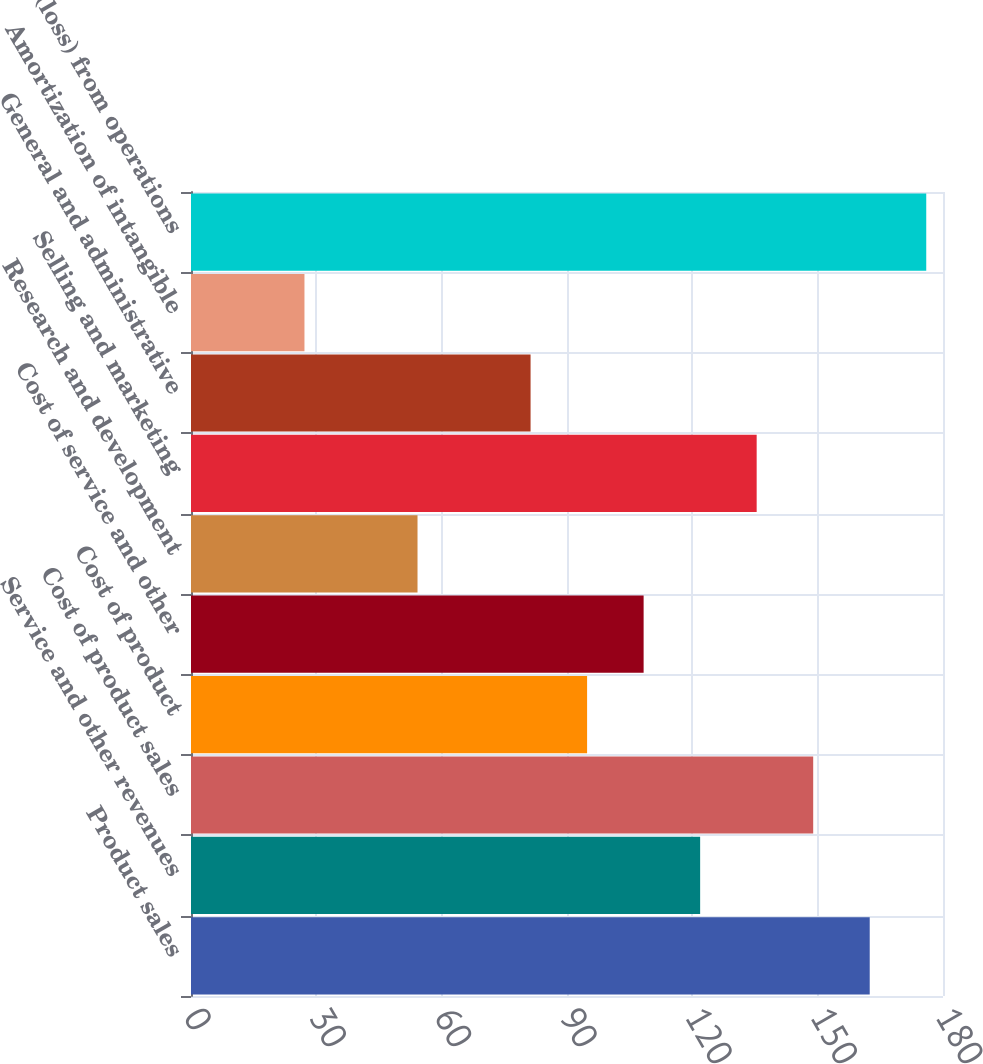<chart> <loc_0><loc_0><loc_500><loc_500><bar_chart><fcel>Product sales<fcel>Service and other revenues<fcel>Cost of product sales<fcel>Cost of product<fcel>Cost of service and other<fcel>Research and development<fcel>Selling and marketing<fcel>General and administrative<fcel>Amortization of intangible<fcel>Income (loss) from operations<nl><fcel>162.46<fcel>121.87<fcel>148.93<fcel>94.81<fcel>108.34<fcel>54.22<fcel>135.4<fcel>81.28<fcel>27.16<fcel>175.99<nl></chart> 